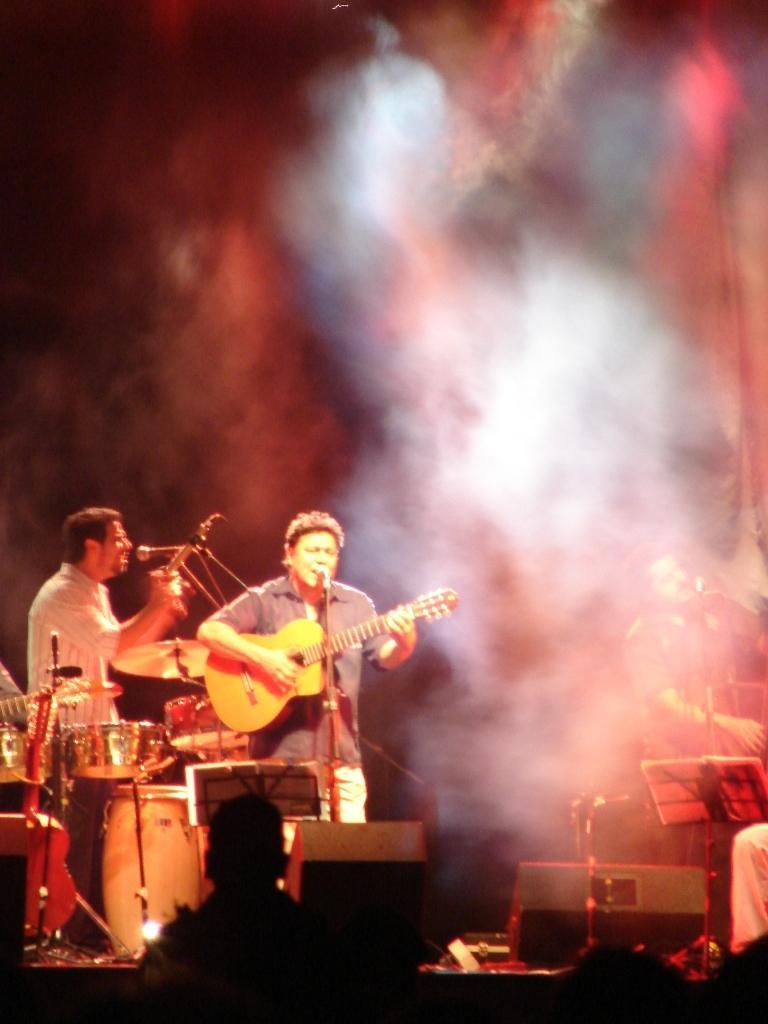Could you give a brief overview of what you see in this image? In this image we can see this person is singing through the mic and playing guitar which is in his hands. This person is playing electronic drums and we can see this person here standing. 